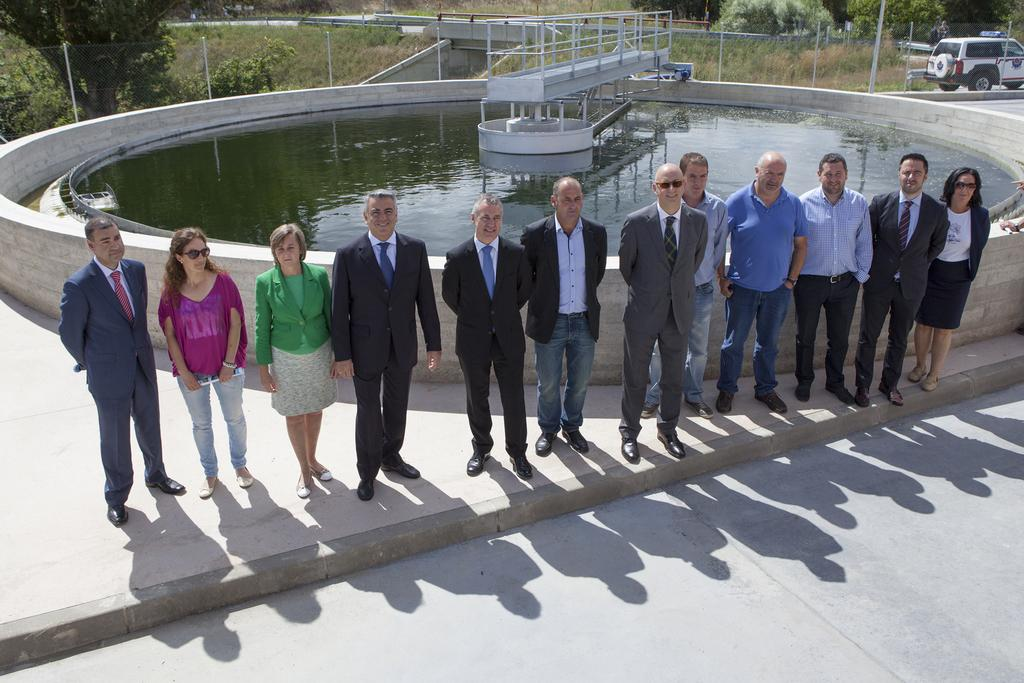How many people are in the image? There are people in the image, but the exact number is not specified. What is the primary element visible in the image? Water is visible in the image. What type of material is present in the image? There is mesh in the image. What type of transportation is in the image? There is a vehicle in the image. What type of vegetation is in the image? There are trees in the image. What type of structures are in the image? There are poles in the image. What other unspecified objects are in the image? There are unspecified objects in the image, but their nature is not described. What type of plough is being used to join the trees in the image? There is no plough present in the image, nor is there any indication of trees being joined. 